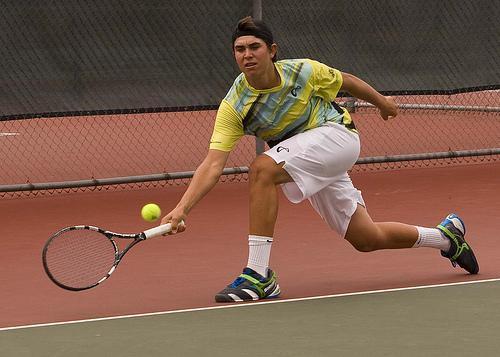How many players are pictured?
Give a very brief answer. 1. 